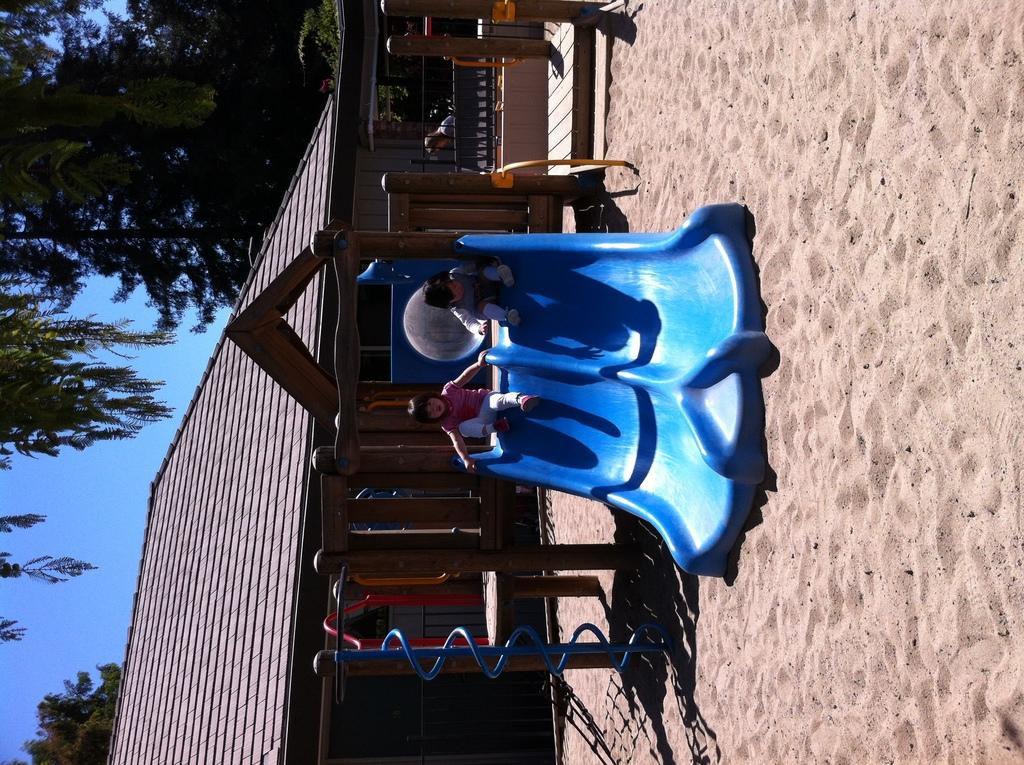How many kids are in the image? There are two kids in the image. What are the kids doing in the image? The kids are on slides. What can be seen in the background of the image? There is a house, a fence, trees, and the sky visible in the background of the image. What is the surface at the bottom of the image? There is sand at the bottom of the image. What type of ornament is hanging from the tree in the image? There is no ornament hanging from the tree in the image; there are only trees visible in the background. Can you tell me how many people the kids are trying to crush in the image? There is no indication in the image that the kids are trying to crush anyone; they are simply on slides. 